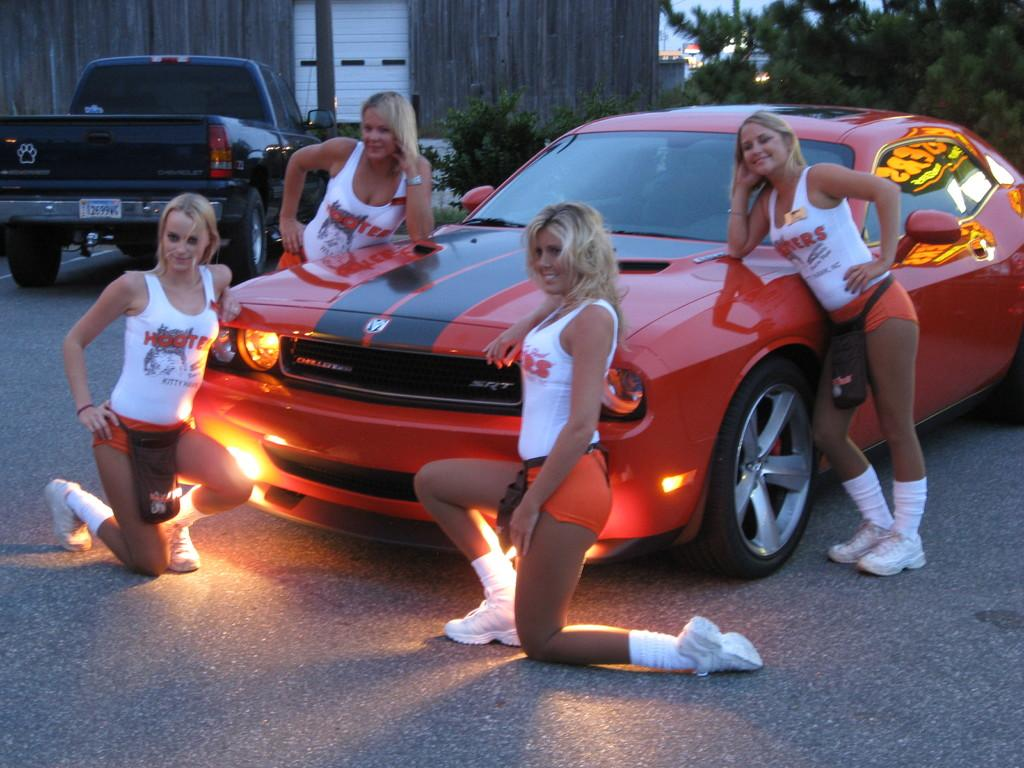What can be seen on the road in the image? There are vehicles on the road in the image. How many people are present in the image? There are four persons in the image. What is located behind the vehicles or people in the image? There is a wall in the image. What type of vegetation is visible in the image? There are trees in the image. What is visible above the vehicles, people, and trees in the image? The sky is visible in the image. Can you tell me how many corks are on the wall in the image? There is no mention of corks in the image; the wall is not described in detail. What type of walk is depicted in the image? There is no walk or walking activity shown in the image; it features vehicles on the road and people near the wall. 